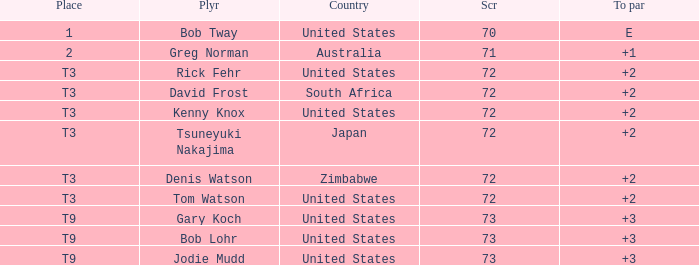What is the top score for tsuneyuki nakajima? 72.0. Parse the full table. {'header': ['Place', 'Plyr', 'Country', 'Scr', 'To par'], 'rows': [['1', 'Bob Tway', 'United States', '70', 'E'], ['2', 'Greg Norman', 'Australia', '71', '+1'], ['T3', 'Rick Fehr', 'United States', '72', '+2'], ['T3', 'David Frost', 'South Africa', '72', '+2'], ['T3', 'Kenny Knox', 'United States', '72', '+2'], ['T3', 'Tsuneyuki Nakajima', 'Japan', '72', '+2'], ['T3', 'Denis Watson', 'Zimbabwe', '72', '+2'], ['T3', 'Tom Watson', 'United States', '72', '+2'], ['T9', 'Gary Koch', 'United States', '73', '+3'], ['T9', 'Bob Lohr', 'United States', '73', '+3'], ['T9', 'Jodie Mudd', 'United States', '73', '+3']]} 